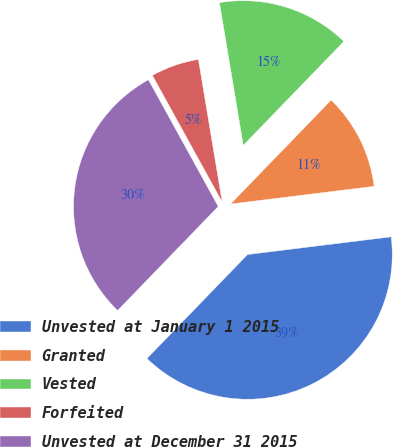Convert chart to OTSL. <chart><loc_0><loc_0><loc_500><loc_500><pie_chart><fcel>Unvested at January 1 2015<fcel>Granted<fcel>Vested<fcel>Forfeited<fcel>Unvested at December 31 2015<nl><fcel>39.19%<fcel>10.81%<fcel>14.87%<fcel>5.38%<fcel>29.75%<nl></chart> 